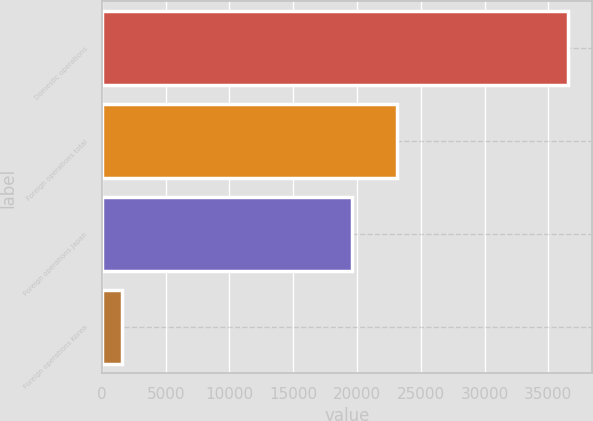<chart> <loc_0><loc_0><loc_500><loc_500><bar_chart><fcel>Domestic operations<fcel>Foreign operations total<fcel>Foreign operations Japan<fcel>Foreign operations Korea<nl><fcel>36573<fcel>23116<fcel>19589<fcel>1567<nl></chart> 